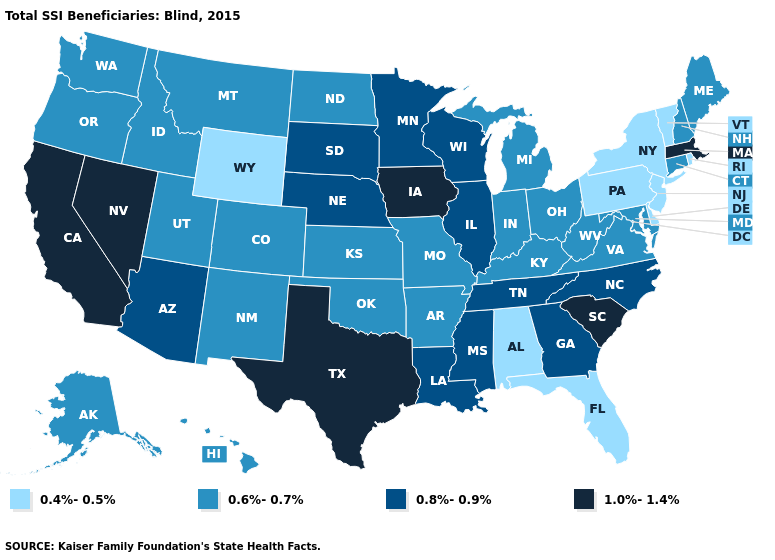Does New Hampshire have the lowest value in the USA?
Keep it brief. No. What is the value of Arkansas?
Write a very short answer. 0.6%-0.7%. Among the states that border Mississippi , which have the highest value?
Be succinct. Louisiana, Tennessee. Name the states that have a value in the range 1.0%-1.4%?
Write a very short answer. California, Iowa, Massachusetts, Nevada, South Carolina, Texas. Name the states that have a value in the range 0.8%-0.9%?
Quick response, please. Arizona, Georgia, Illinois, Louisiana, Minnesota, Mississippi, Nebraska, North Carolina, South Dakota, Tennessee, Wisconsin. Name the states that have a value in the range 0.6%-0.7%?
Short answer required. Alaska, Arkansas, Colorado, Connecticut, Hawaii, Idaho, Indiana, Kansas, Kentucky, Maine, Maryland, Michigan, Missouri, Montana, New Hampshire, New Mexico, North Dakota, Ohio, Oklahoma, Oregon, Utah, Virginia, Washington, West Virginia. Among the states that border Kentucky , which have the lowest value?
Quick response, please. Indiana, Missouri, Ohio, Virginia, West Virginia. What is the value of Maine?
Keep it brief. 0.6%-0.7%. Is the legend a continuous bar?
Answer briefly. No. What is the lowest value in states that border Utah?
Short answer required. 0.4%-0.5%. What is the value of Georgia?
Quick response, please. 0.8%-0.9%. Name the states that have a value in the range 1.0%-1.4%?
Give a very brief answer. California, Iowa, Massachusetts, Nevada, South Carolina, Texas. Name the states that have a value in the range 1.0%-1.4%?
Quick response, please. California, Iowa, Massachusetts, Nevada, South Carolina, Texas. Name the states that have a value in the range 1.0%-1.4%?
Short answer required. California, Iowa, Massachusetts, Nevada, South Carolina, Texas. 